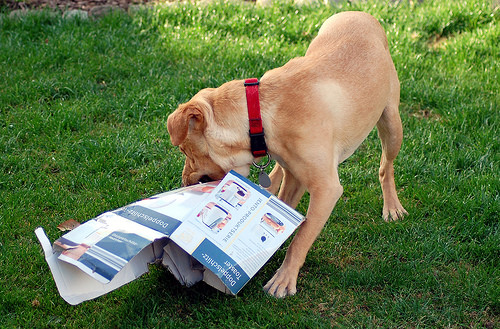<image>
Is there a dog in the grass? No. The dog is not contained within the grass. These objects have a different spatial relationship. Is the dog collar above the box? Yes. The dog collar is positioned above the box in the vertical space, higher up in the scene. 